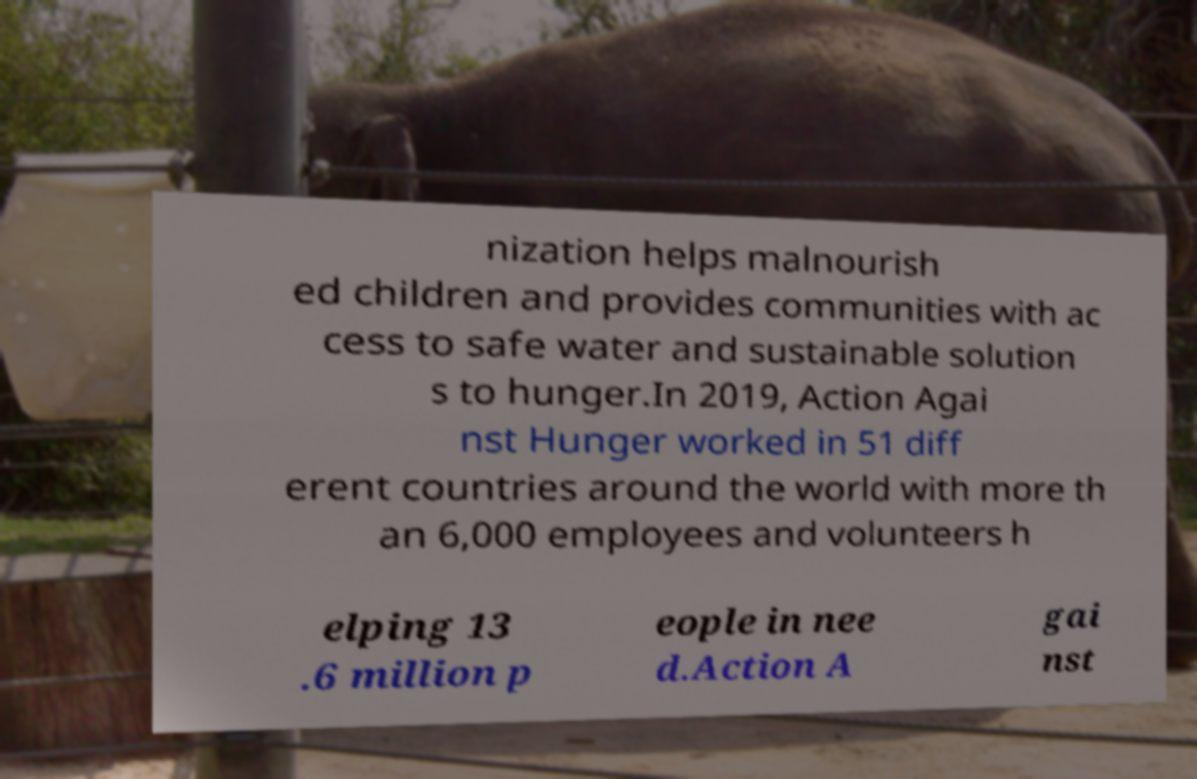What messages or text are displayed in this image? I need them in a readable, typed format. nization helps malnourish ed children and provides communities with ac cess to safe water and sustainable solution s to hunger.In 2019, Action Agai nst Hunger worked in 51 diff erent countries around the world with more th an 6,000 employees and volunteers h elping 13 .6 million p eople in nee d.Action A gai nst 